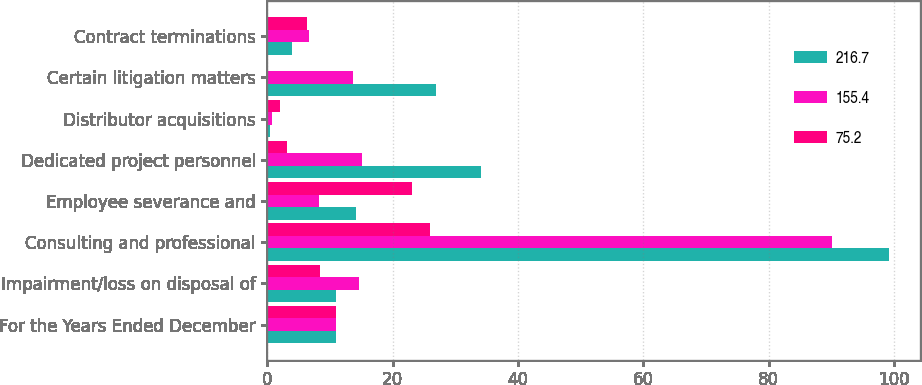Convert chart. <chart><loc_0><loc_0><loc_500><loc_500><stacked_bar_chart><ecel><fcel>For the Years Ended December<fcel>Impairment/loss on disposal of<fcel>Consulting and professional<fcel>Employee severance and<fcel>Dedicated project personnel<fcel>Distributor acquisitions<fcel>Certain litigation matters<fcel>Contract terminations<nl><fcel>216.7<fcel>10.9<fcel>10.9<fcel>99.1<fcel>14.2<fcel>34<fcel>0.4<fcel>26.9<fcel>3.9<nl><fcel>155.4<fcel>10.9<fcel>14.6<fcel>90.1<fcel>8.2<fcel>15.1<fcel>0.8<fcel>13.7<fcel>6.6<nl><fcel>75.2<fcel>10.9<fcel>8.4<fcel>26<fcel>23.1<fcel>3.2<fcel>2<fcel>0.1<fcel>6.3<nl></chart> 